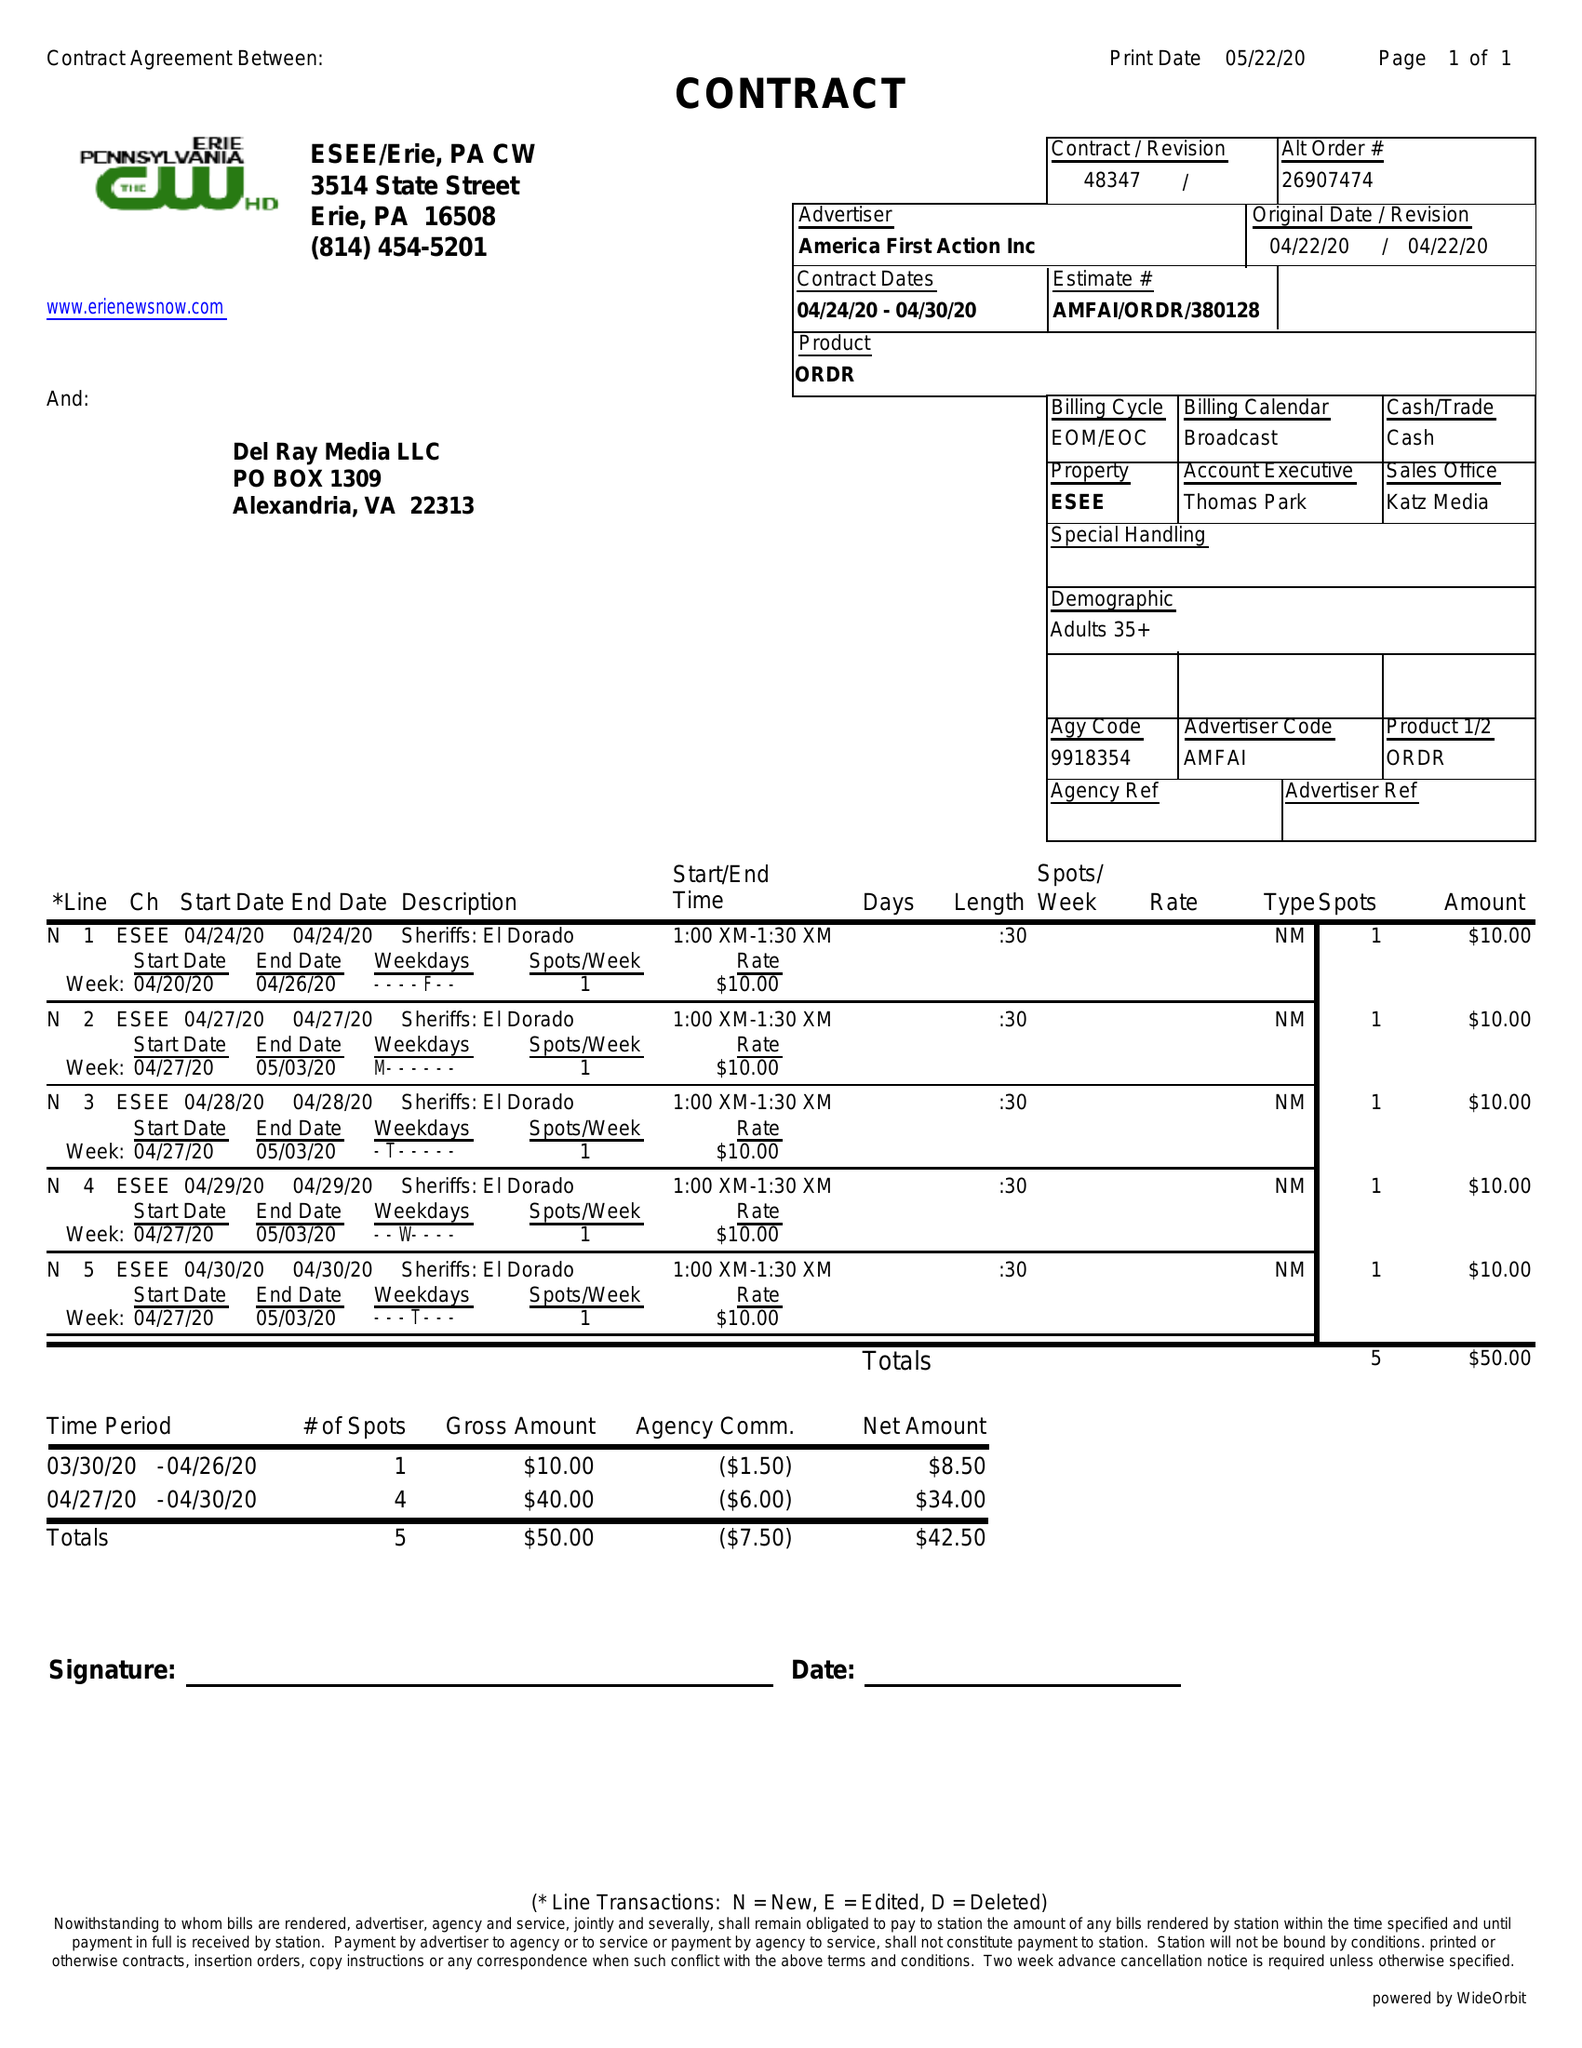What is the value for the gross_amount?
Answer the question using a single word or phrase. 50.00 